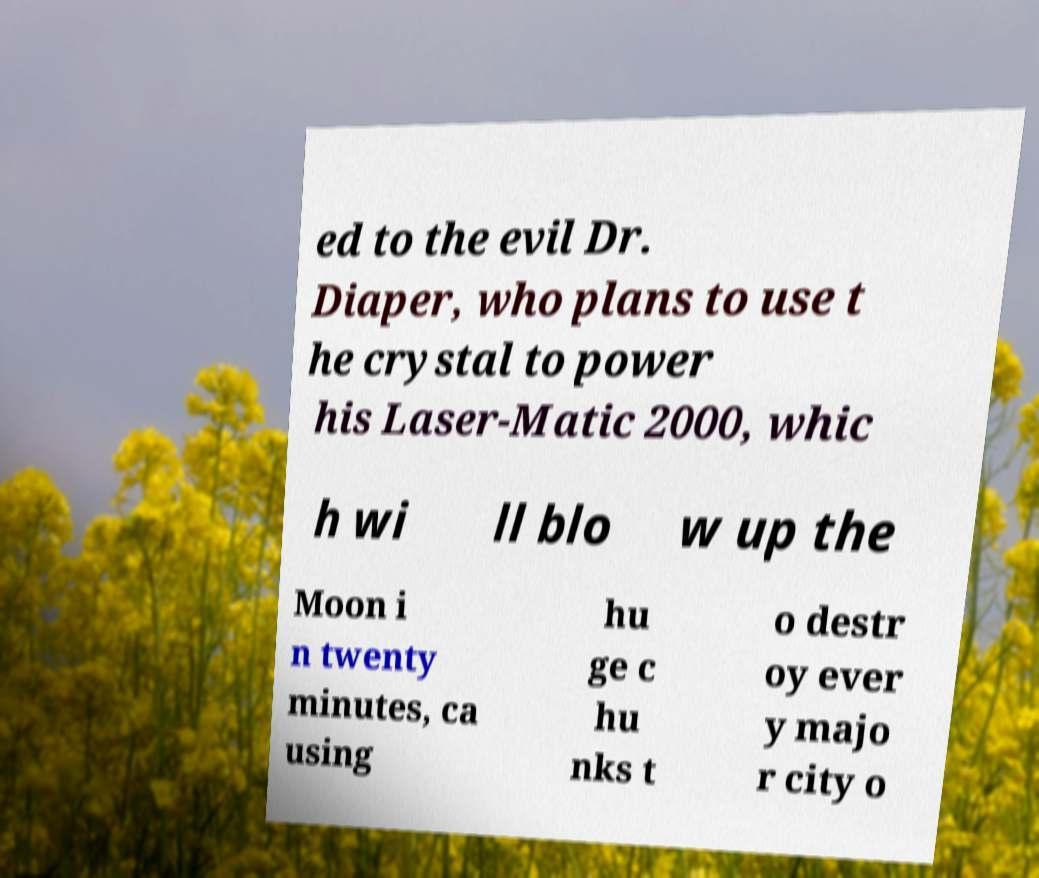What messages or text are displayed in this image? I need them in a readable, typed format. ed to the evil Dr. Diaper, who plans to use t he crystal to power his Laser-Matic 2000, whic h wi ll blo w up the Moon i n twenty minutes, ca using hu ge c hu nks t o destr oy ever y majo r city o 